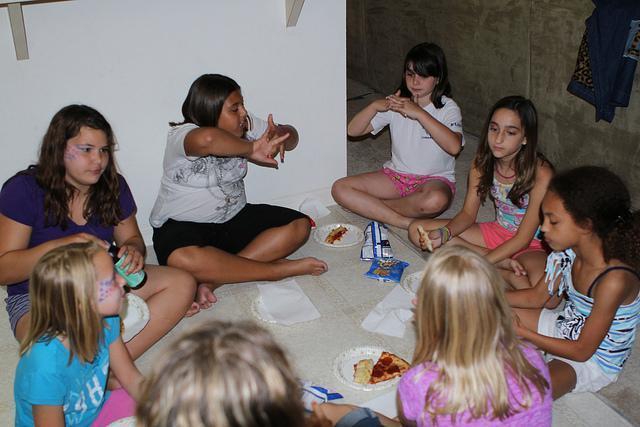How many girls are wearing pink?
Give a very brief answer. 4. How many people are visible?
Give a very brief answer. 8. 